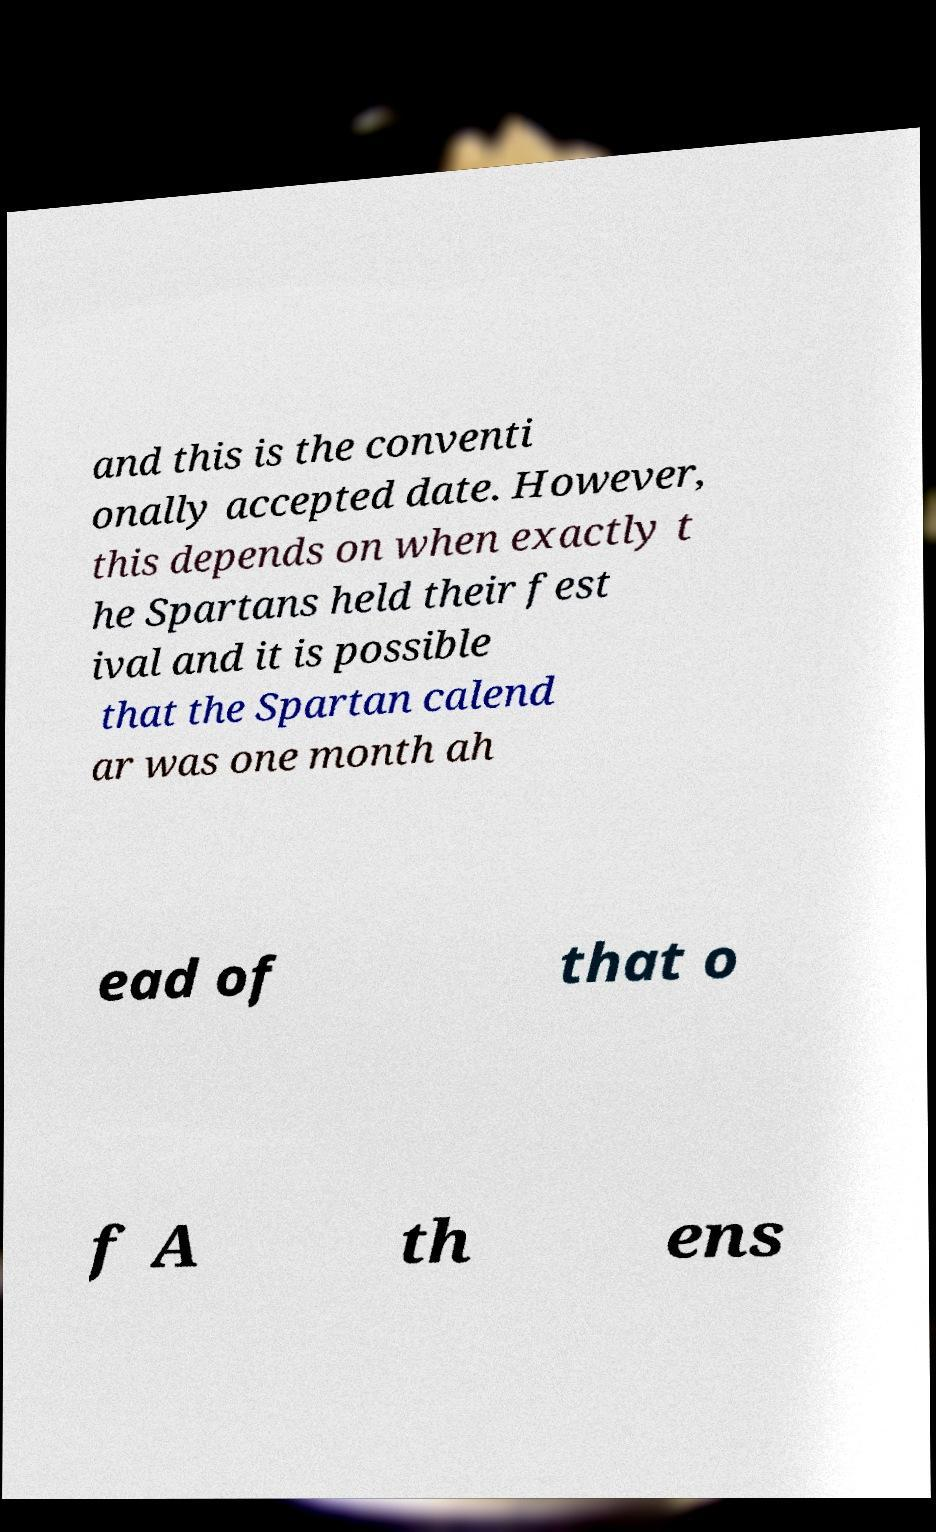Can you read and provide the text displayed in the image?This photo seems to have some interesting text. Can you extract and type it out for me? and this is the conventi onally accepted date. However, this depends on when exactly t he Spartans held their fest ival and it is possible that the Spartan calend ar was one month ah ead of that o f A th ens 